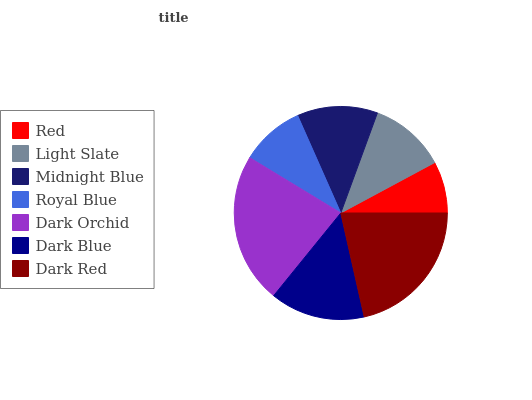Is Red the minimum?
Answer yes or no. Yes. Is Dark Orchid the maximum?
Answer yes or no. Yes. Is Light Slate the minimum?
Answer yes or no. No. Is Light Slate the maximum?
Answer yes or no. No. Is Light Slate greater than Red?
Answer yes or no. Yes. Is Red less than Light Slate?
Answer yes or no. Yes. Is Red greater than Light Slate?
Answer yes or no. No. Is Light Slate less than Red?
Answer yes or no. No. Is Midnight Blue the high median?
Answer yes or no. Yes. Is Midnight Blue the low median?
Answer yes or no. Yes. Is Red the high median?
Answer yes or no. No. Is Royal Blue the low median?
Answer yes or no. No. 